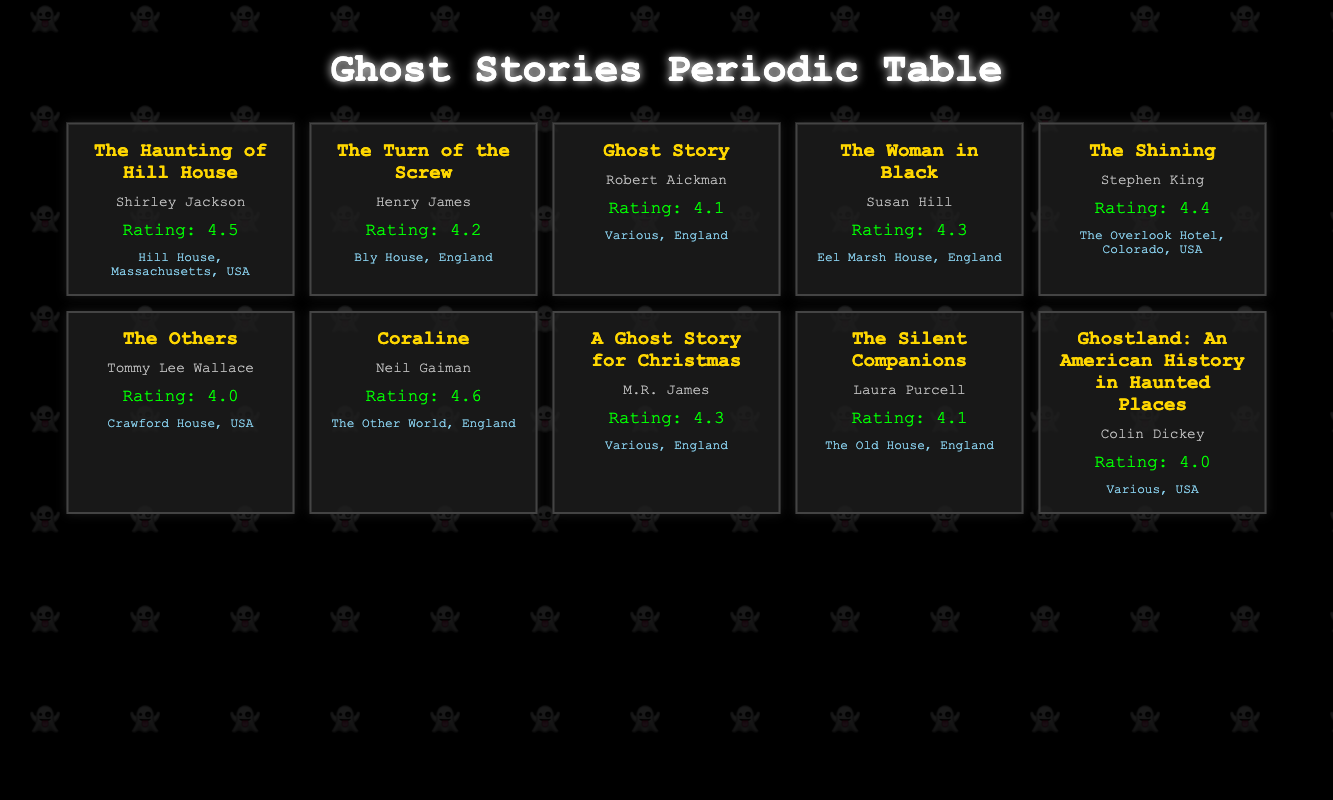What is the reader rating for "Coraline"? The rating for "Coraline" is directly listed in the table, which shows the title of the story and its reader rating.
Answer: 4.6 Which ghost story has the highest reader rating? By comparing the ratings listed for each story, "Coraline" has the highest rating at 4.6.
Answer: "Coraline" How many stories have a reader rating of 4.0 or lower? The stories "The Others" and "Ghostland: An American History in Haunted Places" both have a reader rating of 4.0. Therefore, there are 2 stories with a rating of 4.0 or lower.
Answer: 2 What is the average reader rating of all the ghost stories listed in the table? The ratings to sum are 4.5, 4.2, 4.1, 4.3, 4.4, 4.0, 4.6, 4.3, 4.1, and 4.0. The total sum is 43.1, and there are 10 stories. Therefore, the average is 43.1/10 = 4.31.
Answer: 4.31 Does "The Woman in Black" have a higher rating than "The Silent Companions"? "The Woman in Black" has a rating of 4.3, while "The Silent Companions" has a rating of 4.1. Since 4.3 is greater than 4.1, the statement is true.
Answer: Yes Which two stories are set in England and have the same rating? The two stories "The Woman in Black" and "A Ghost Story for Christmas" both have a rating of 4.3 and are set in England.
Answer: "The Woman in Black" and "A Ghost Story for Christmas" What is the setting of "The Shining"? The table specifies "The Overlook Hotel, Colorado, USA" as the setting for "The Shining".
Answer: The Overlook Hotel, Colorado, USA Is "The Haunting of Hill House" rated higher than "Ghost Story"? "The Haunting of Hill House" has a rating of 4.5, while "Ghost Story" has a rating of 4.1. Since 4.5 is greater than 4.1, the answer is true.
Answer: Yes 